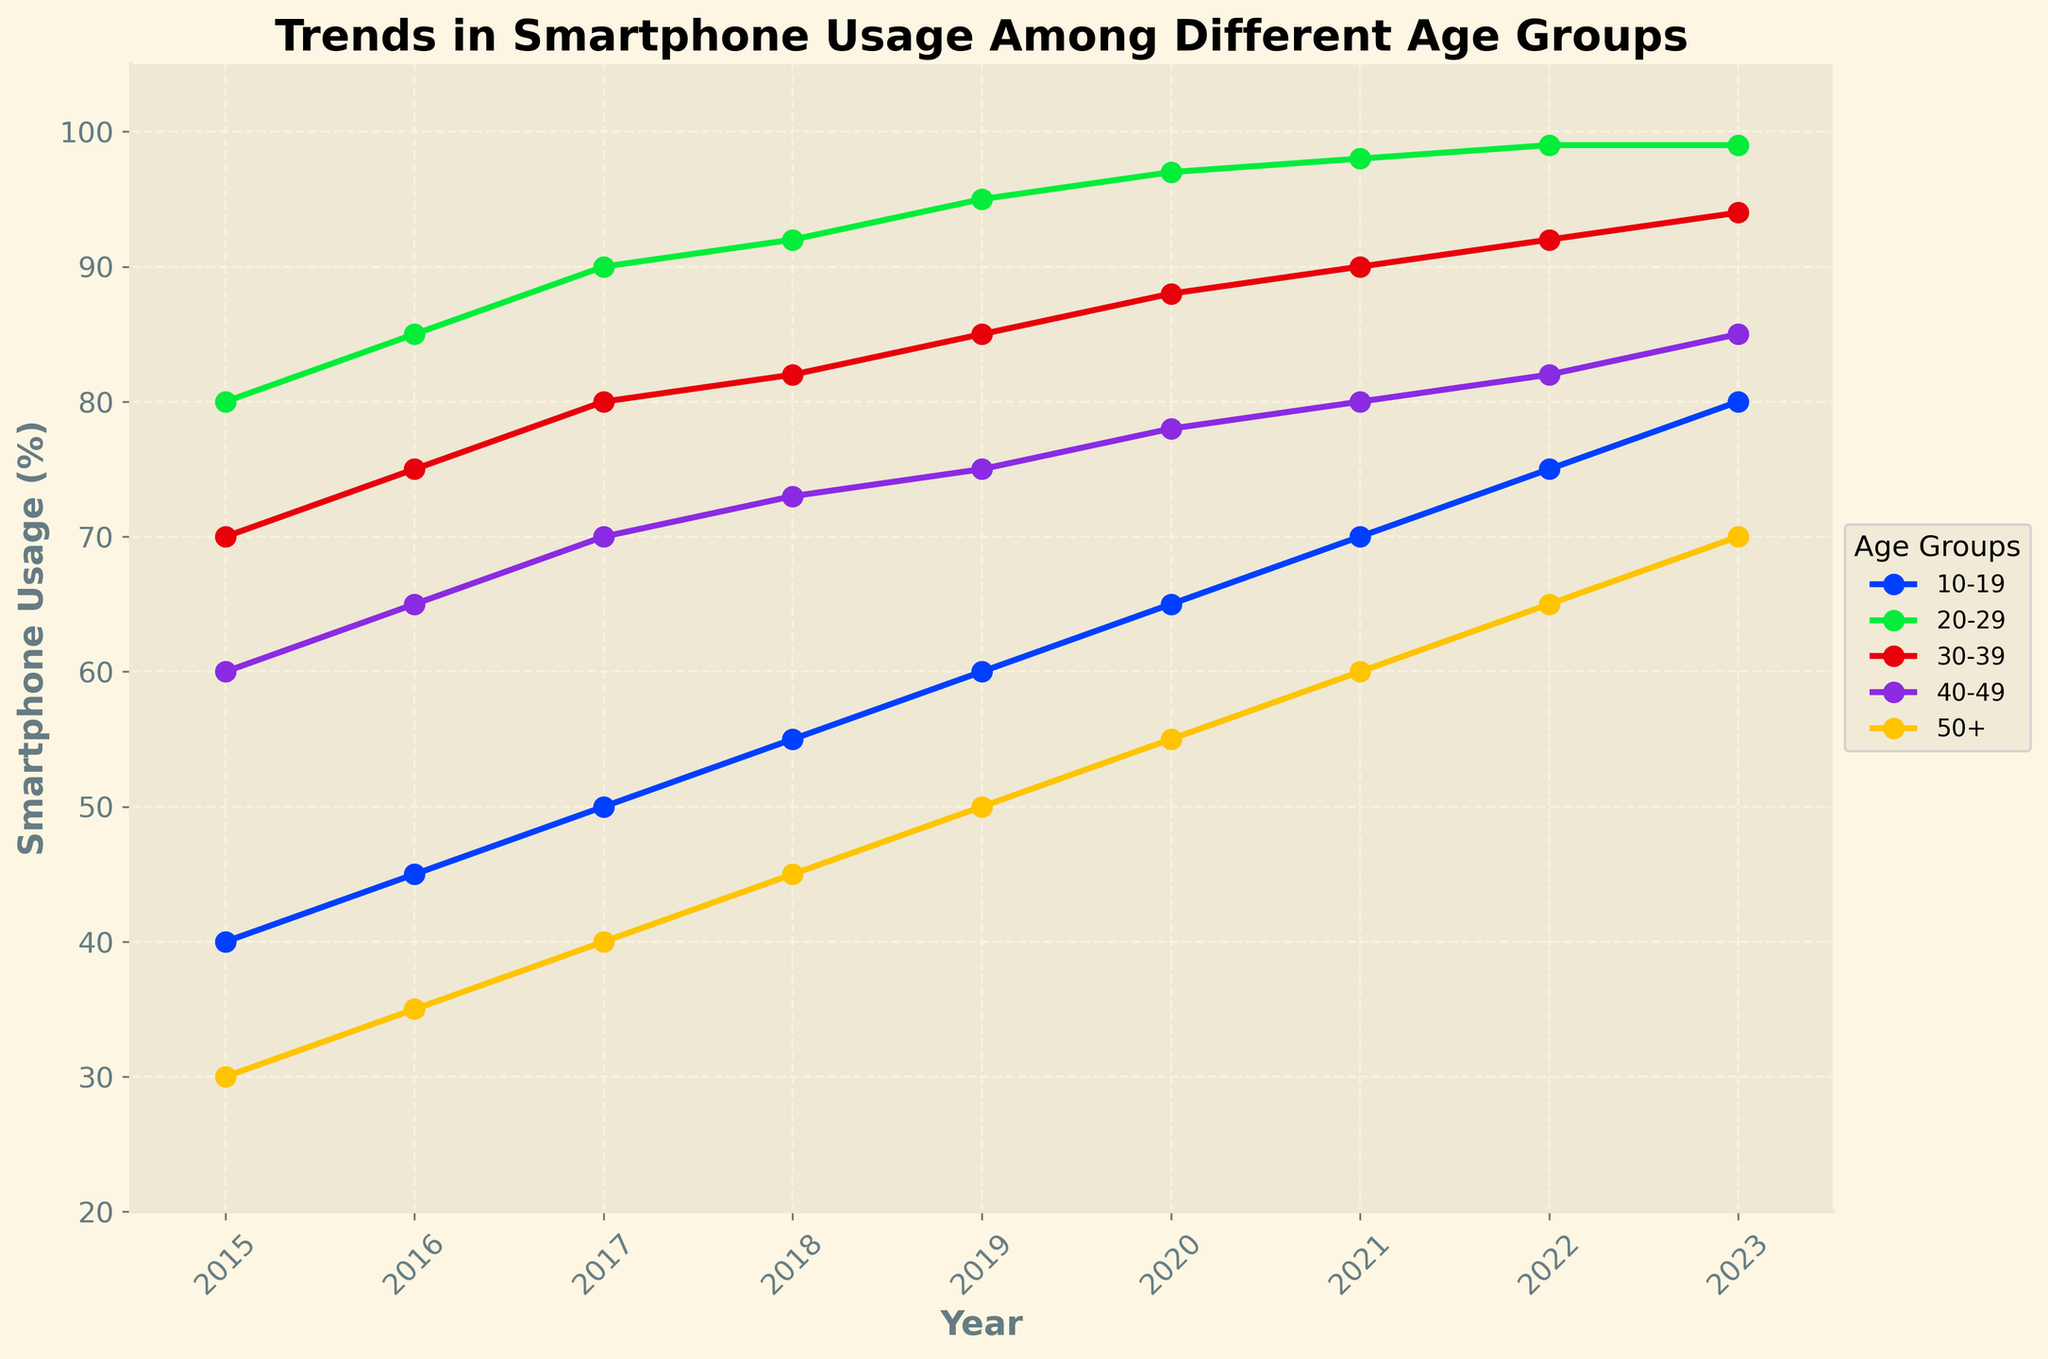What's the title of the plot? Look at the top of the figure where the title is prominently displayed.
Answer: Trends in Smartphone Usage Among Different Age Groups Which year shows the highest smartphone usage for the age group 10-19? Identify the highest point on the line representing the age group 10-19 and match it to the corresponding year on the x-axis.
Answer: 2023 In which year is the smartphone usage among the 50+ age group 55%? Find the point on the line representing the 50+ age group that corresponds to 55% on the y-axis and match it to the corresponding year on the x-axis.
Answer: 2020 What's the difference in smartphone usage between the age groups 20-29 and 40-49 in 2022? Look at the points for both age groups in 2022, observe their y-values, and subtract the usage of 40-49 from 20-29.
Answer: 17% Between which years did the age group 30-39 see the biggest increase in smartphone usage? Compare the vertical distance between consecutive points along the 30-39 line to find the biggest increase.
Answer: 2015 to 2016 What was the average smartphone usage for the age group 10-19 from 2015 to 2023? Sum up the y-values for the 10-19 age group from 2015 to 2023 and then divide by the number of years.
Answer: (40+45+50+55+60+65+70+75+80) / 9 = 60% Which age group's smartphone usage reached 99% first? Identify when each age group’s usage reached 99% by looking at their respective lines and corresponding years.
Answer: 20-29 Which age group had the least increase in smartphone usage from 2015 to 2023? Calculate the difference between the 2023 and 2015 values for each age group and compare them to find the smallest increase.
Answer: 50+ When did the 40-49 age group surpass 80% smartphone usage? Look at the points on the 40-49 line to see when it first reaches above 80% on the y-axis.
Answer: 2023 Did any age group have a year-over-year decline in smartphone usage between 2015 and 2023? Check each line to see if there's any year where the line goes downward instead of upward.
Answer: No 